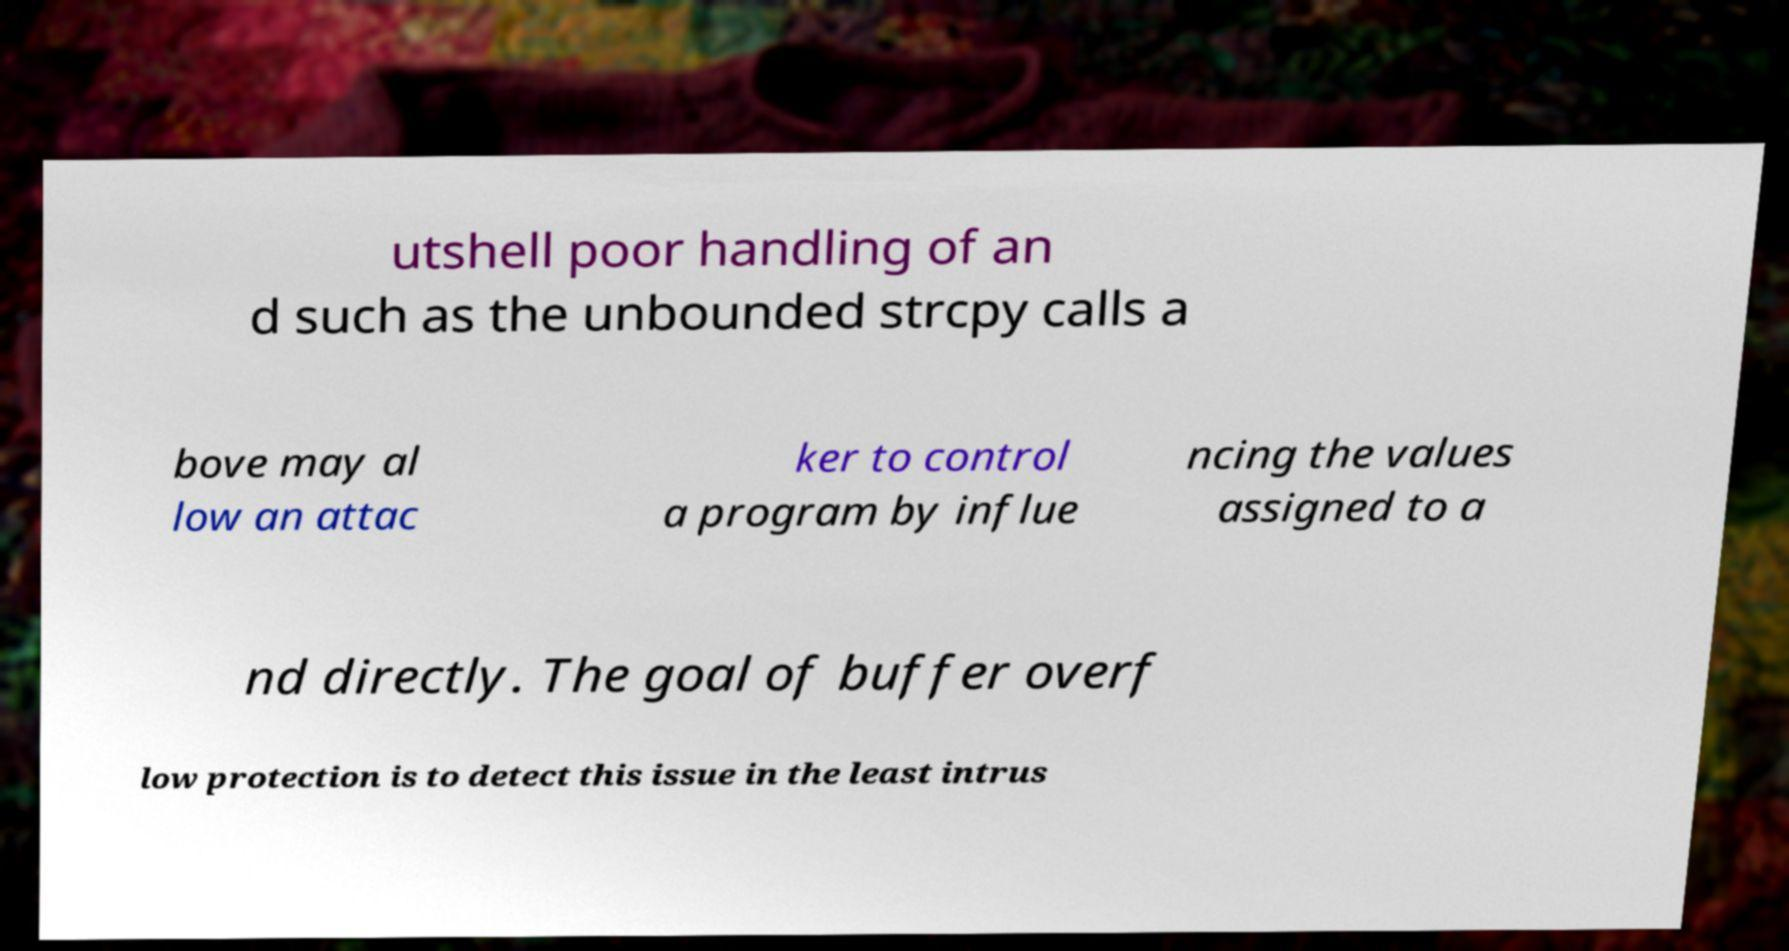For documentation purposes, I need the text within this image transcribed. Could you provide that? utshell poor handling of an d such as the unbounded strcpy calls a bove may al low an attac ker to control a program by influe ncing the values assigned to a nd directly. The goal of buffer overf low protection is to detect this issue in the least intrus 